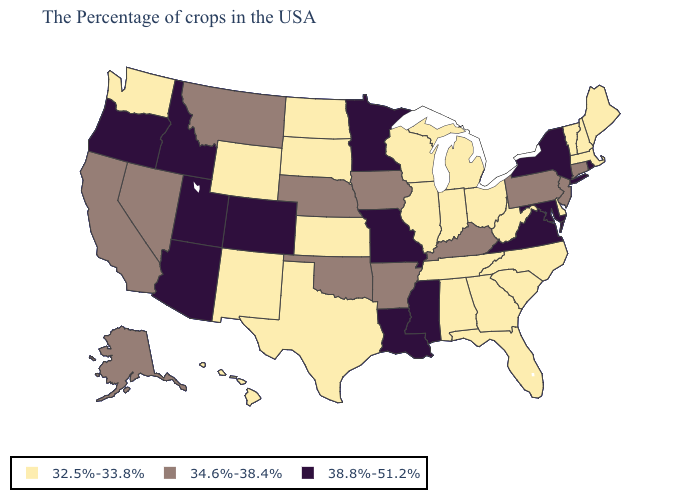What is the highest value in states that border South Dakota?
Quick response, please. 38.8%-51.2%. Does Louisiana have the lowest value in the USA?
Quick response, please. No. What is the lowest value in the Northeast?
Keep it brief. 32.5%-33.8%. What is the value of Nevada?
Give a very brief answer. 34.6%-38.4%. Among the states that border Kentucky , which have the lowest value?
Answer briefly. West Virginia, Ohio, Indiana, Tennessee, Illinois. Does the first symbol in the legend represent the smallest category?
Be succinct. Yes. Which states have the lowest value in the South?
Concise answer only. Delaware, North Carolina, South Carolina, West Virginia, Florida, Georgia, Alabama, Tennessee, Texas. Name the states that have a value in the range 38.8%-51.2%?
Write a very short answer. Rhode Island, New York, Maryland, Virginia, Mississippi, Louisiana, Missouri, Minnesota, Colorado, Utah, Arizona, Idaho, Oregon. Name the states that have a value in the range 38.8%-51.2%?
Give a very brief answer. Rhode Island, New York, Maryland, Virginia, Mississippi, Louisiana, Missouri, Minnesota, Colorado, Utah, Arizona, Idaho, Oregon. What is the value of Nebraska?
Answer briefly. 34.6%-38.4%. Does New York have the highest value in the Northeast?
Be succinct. Yes. Name the states that have a value in the range 38.8%-51.2%?
Concise answer only. Rhode Island, New York, Maryland, Virginia, Mississippi, Louisiana, Missouri, Minnesota, Colorado, Utah, Arizona, Idaho, Oregon. Does North Carolina have a higher value than Delaware?
Concise answer only. No. What is the value of Connecticut?
Concise answer only. 34.6%-38.4%. Name the states that have a value in the range 38.8%-51.2%?
Write a very short answer. Rhode Island, New York, Maryland, Virginia, Mississippi, Louisiana, Missouri, Minnesota, Colorado, Utah, Arizona, Idaho, Oregon. 